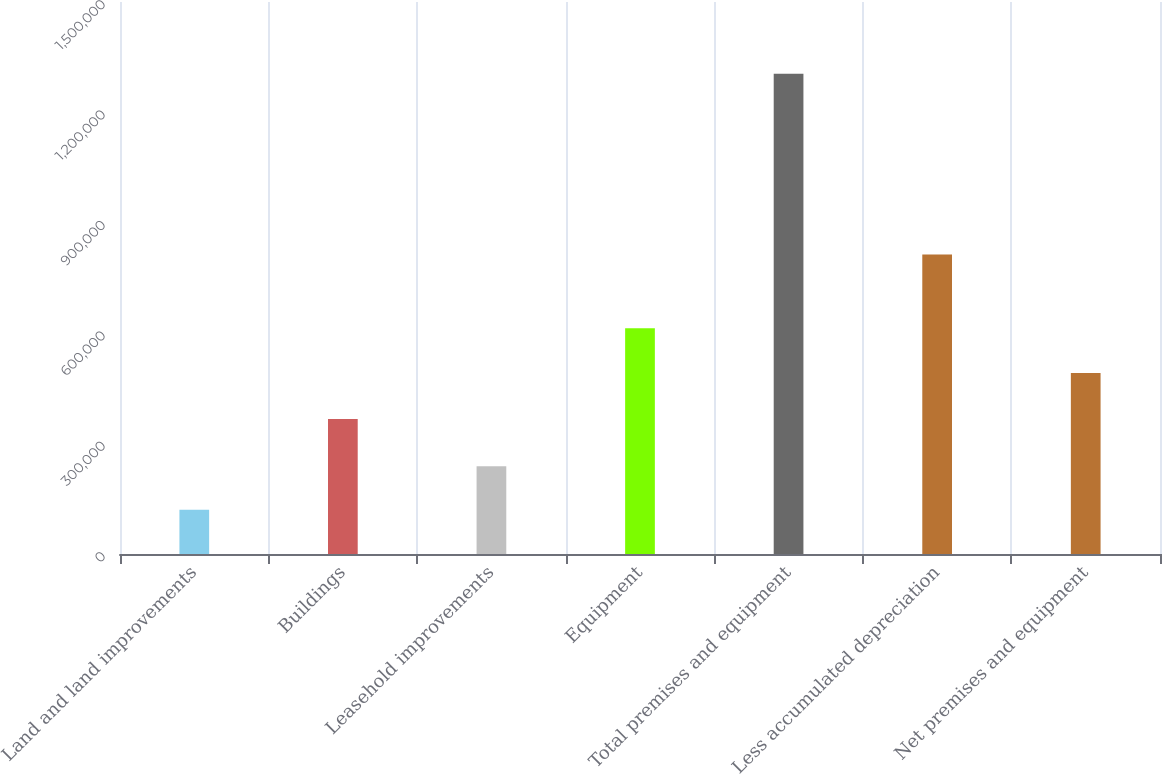Convert chart. <chart><loc_0><loc_0><loc_500><loc_500><bar_chart><fcel>Land and land improvements<fcel>Buildings<fcel>Leasehold improvements<fcel>Equipment<fcel>Total premises and equipment<fcel>Less accumulated depreciation<fcel>Net premises and equipment<nl><fcel>120069<fcel>367003<fcel>238582<fcel>613301<fcel>1.3052e+06<fcel>813601<fcel>491602<nl></chart> 